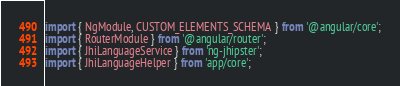Convert code to text. <code><loc_0><loc_0><loc_500><loc_500><_TypeScript_>import { NgModule, CUSTOM_ELEMENTS_SCHEMA } from '@angular/core';
import { RouterModule } from '@angular/router';
import { JhiLanguageService } from 'ng-jhipster';
import { JhiLanguageHelper } from 'app/core';</code> 